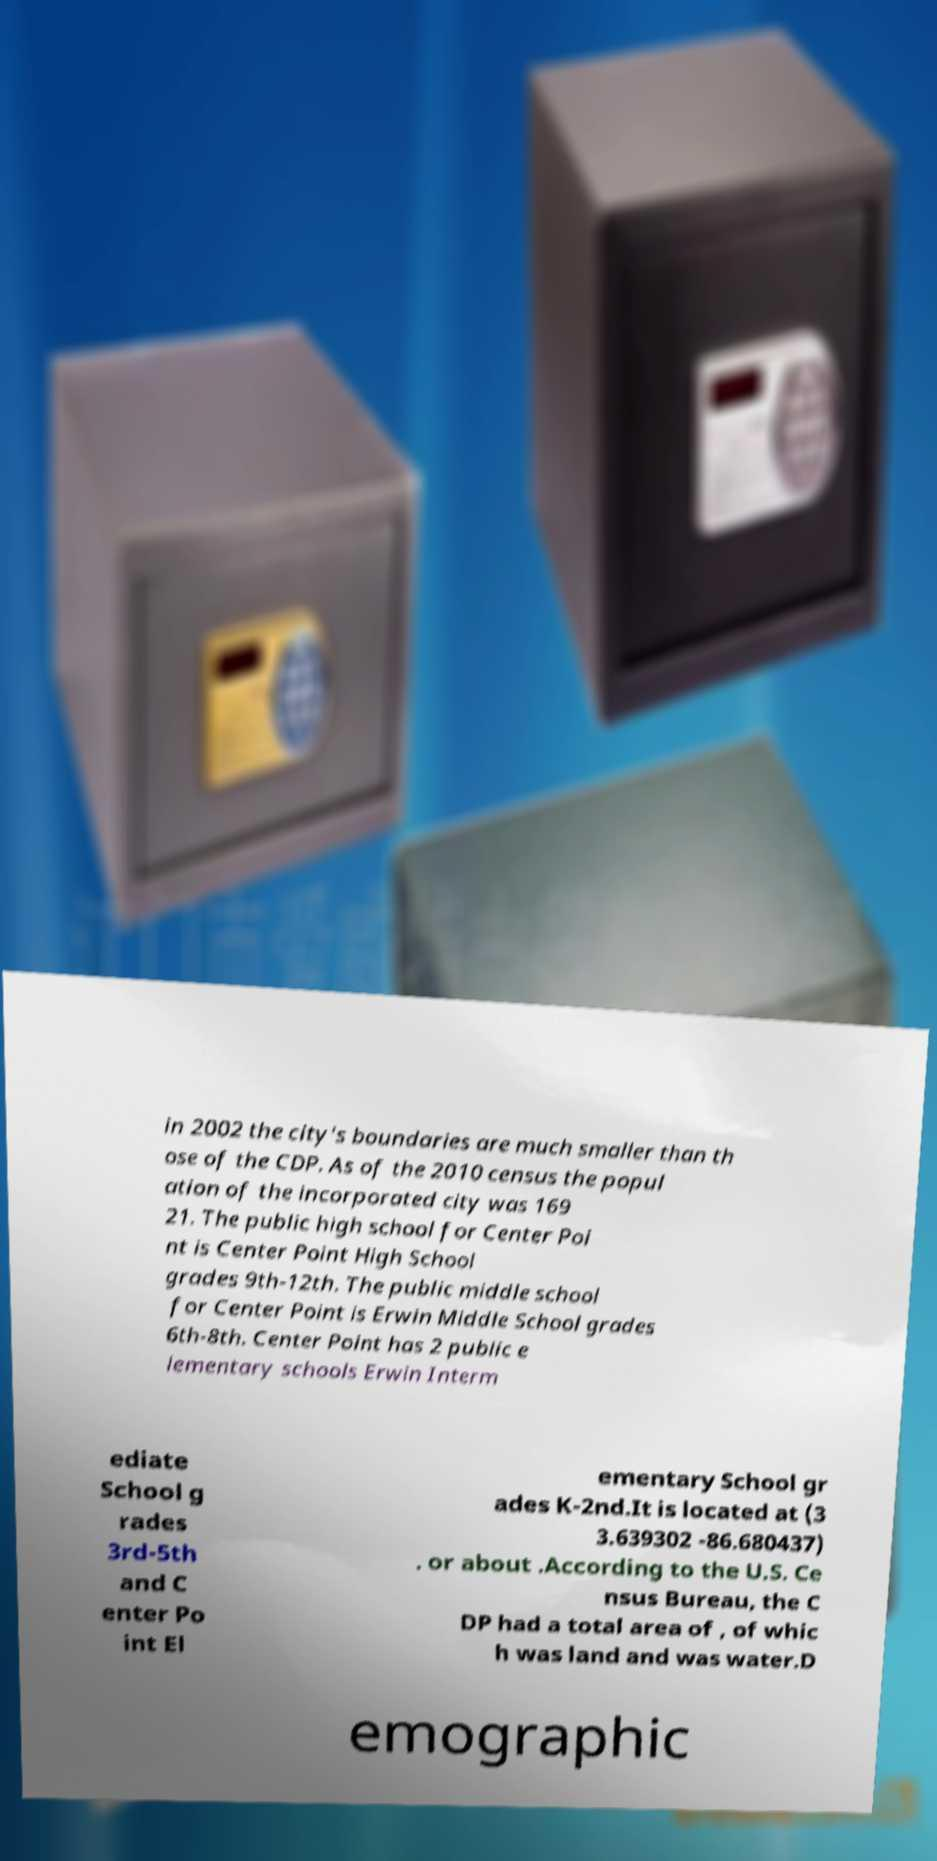Please identify and transcribe the text found in this image. in 2002 the city's boundaries are much smaller than th ose of the CDP. As of the 2010 census the popul ation of the incorporated city was 169 21. The public high school for Center Poi nt is Center Point High School grades 9th-12th. The public middle school for Center Point is Erwin Middle School grades 6th-8th. Center Point has 2 public e lementary schools Erwin Interm ediate School g rades 3rd-5th and C enter Po int El ementary School gr ades K-2nd.It is located at (3 3.639302 -86.680437) . or about .According to the U.S. Ce nsus Bureau, the C DP had a total area of , of whic h was land and was water.D emographic 